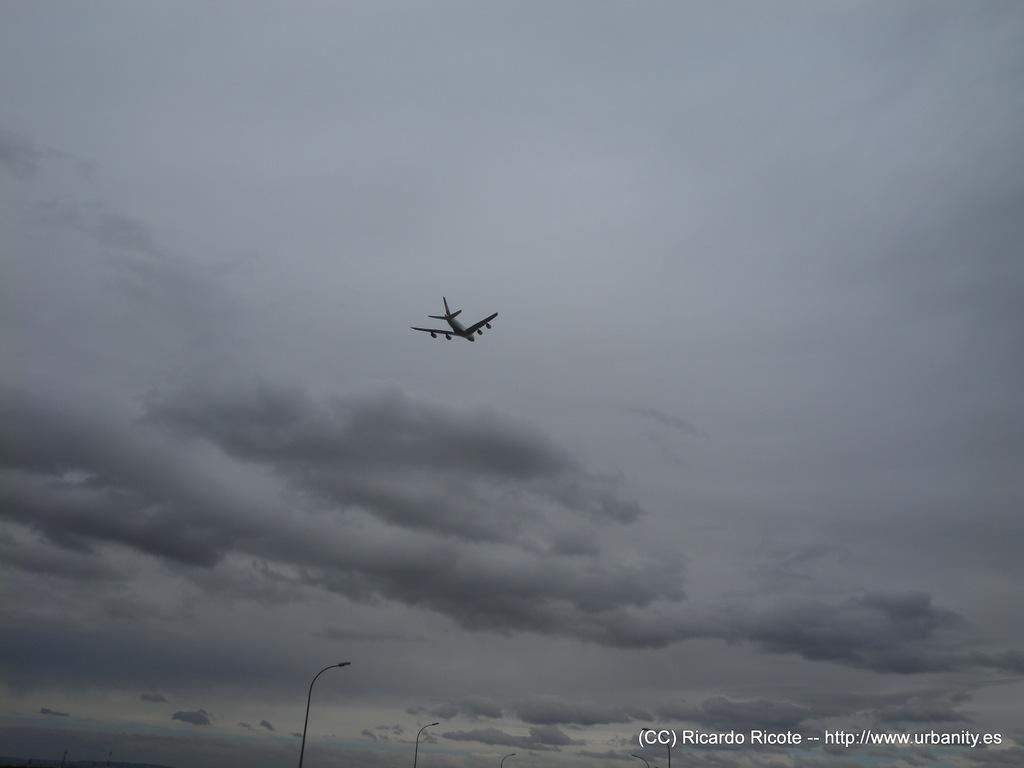What is the main subject of the image? There is an aircraft in the image. What can be seen in the background of the image? There are light poles in the background of the image. How would you describe the color of the sky in the image? The sky is a combination of white and gray colors. How many spiders are crawling on the aircraft in the image? There are no spiders present in the image. What type of crime is being committed in the image? There is no crime depicted in the image; it features an aircraft and light poles in the background. 